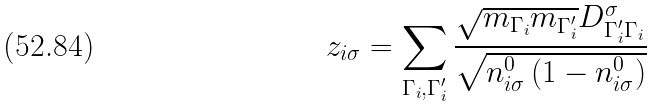<formula> <loc_0><loc_0><loc_500><loc_500>z _ { i \sigma } = \sum _ { \Gamma _ { i } , \Gamma _ { i } ^ { \prime } } \frac { \sqrt { m _ { \Gamma _ { i } } m _ { \Gamma _ { i } ^ { \prime } } } D _ { \Gamma _ { i } ^ { \prime } \Gamma _ { i } } ^ { \sigma } } { \sqrt { n _ { i \sigma } ^ { 0 } \left ( 1 - n _ { i \sigma } ^ { 0 } \right ) } }</formula> 